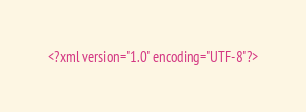Convert code to text. <code><loc_0><loc_0><loc_500><loc_500><_XML_><?xml version="1.0" encoding="UTF-8"?></code> 